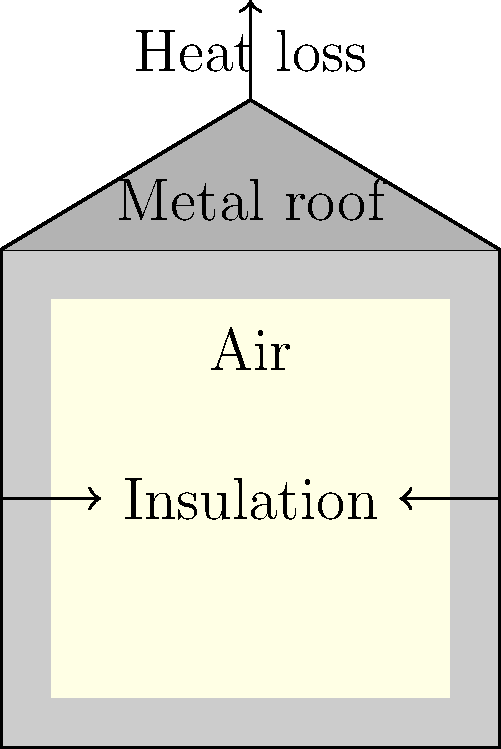Based on the diagram illustrating heat transfer in a pet house, which material modification would most effectively reduce heat loss and improve energy efficiency while minimizing environmental impact? To answer this question, we need to consider the heat transfer properties of the materials shown in the diagram and their environmental implications:

1. The pet house consists of three main components: insulation walls, a metal roof, and an air space inside.

2. Heat transfer occurs through three mechanisms: conduction, convection, and radiation.

3. The insulation walls are designed to reduce conduction heat loss. Improving the insulation material or increasing its thickness would further reduce heat loss.

4. The metal roof conducts heat quickly, leading to significant heat loss. Replacing it with a more insulating material or adding an insulating layer beneath it would improve energy efficiency.

5. The air space inside acts as an insulator but can lead to convection currents that transfer heat.

6. From an environmental perspective, we need to consider:
   a) The production and disposal impact of materials
   b) The longevity and durability of materials
   c) The potential for using recycled or sustainable materials

7. Considering all these factors, the most effective modification would be to replace the metal roof with a more insulating material, such as recycled plastic or sustainable wood products. This would:
   a) Significantly reduce heat loss through the roof
   b) Potentially use recycled or sustainable materials, reducing environmental impact
   c) Maintain or improve the durability of the structure

8. This modification addresses the main source of heat loss (the metal roof) while also considering environmental factors, making it the most effective solution for both energy efficiency and environmental impact.
Answer: Replace metal roof with insulating, sustainable material 